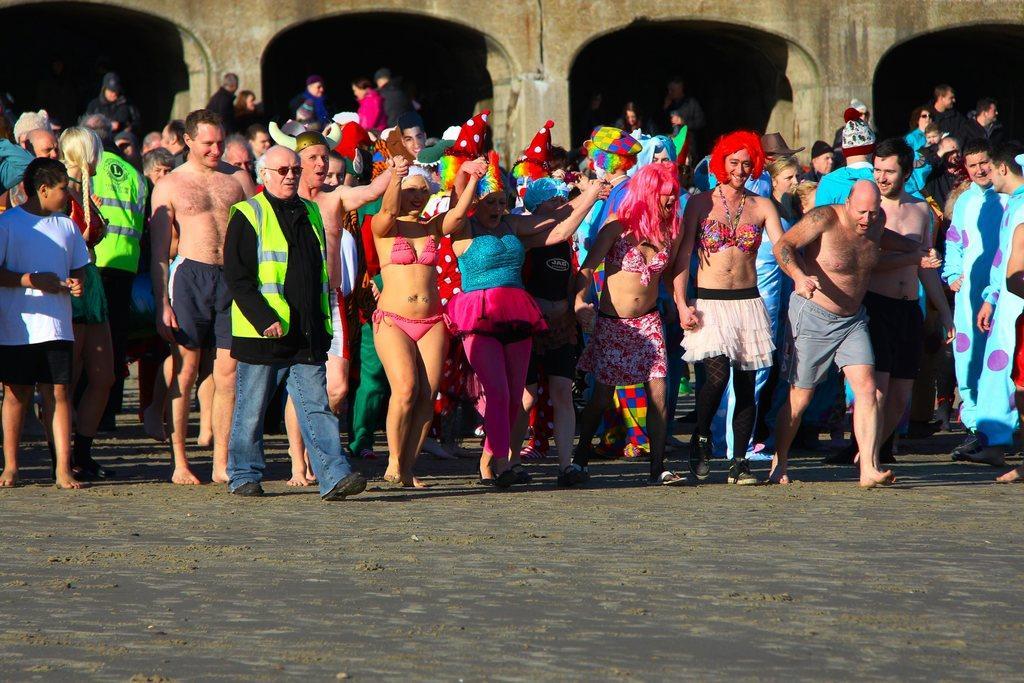Can you describe this image briefly? In this image we can see a crowd. In the back there is a building with arches and pillars. Some are wearing caps. 